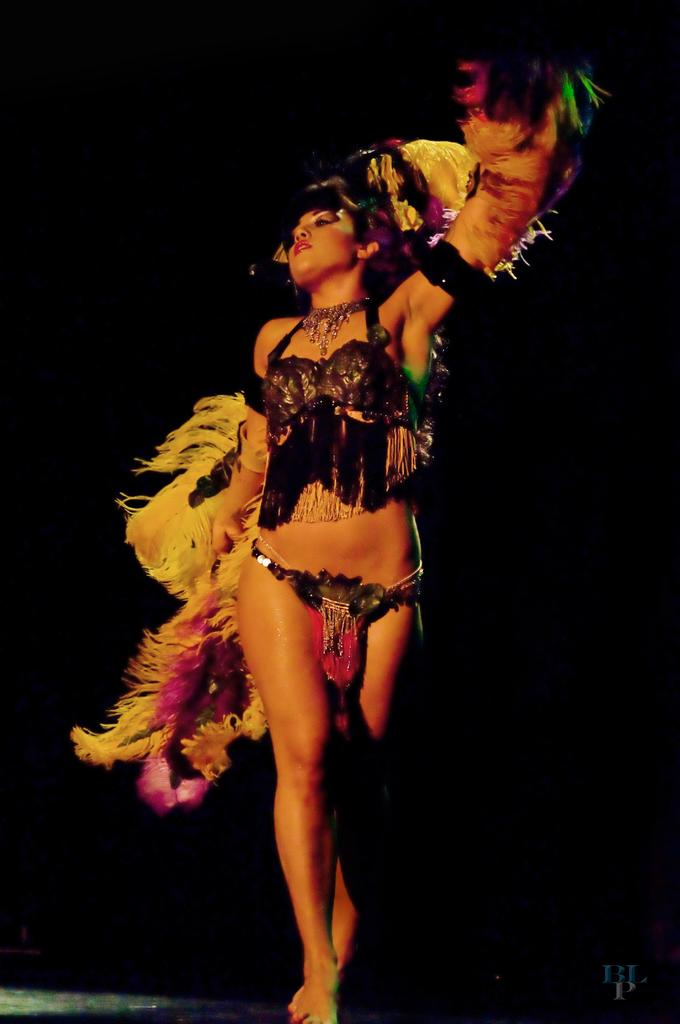Who is the main subject in the image? There is a lady in the center of the image. What is the lady wearing? The lady is wearing a costume. What can be observed about the background of the image? The background of the image is dark. Is there any text present in the image? Yes, there is some text at the bottom of the image. What type of stone can be seen in the lady's hand in the image? There is no stone present in the lady's hand or in the image. Can you describe the grassy area where the lady is standing in the image? There is no grassy area in the image; the lady is standing in a location with a dark background. 